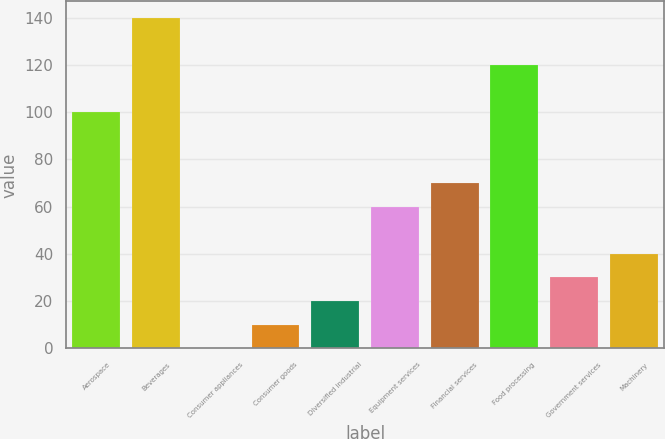<chart> <loc_0><loc_0><loc_500><loc_500><bar_chart><fcel>Aerospace<fcel>Beverages<fcel>Consumer appliances<fcel>Consumer goods<fcel>Diversified industrial<fcel>Equipment services<fcel>Financial services<fcel>Food processing<fcel>Government services<fcel>Machinery<nl><fcel>100<fcel>139.96<fcel>0.1<fcel>10.09<fcel>20.08<fcel>60.04<fcel>70.03<fcel>119.98<fcel>30.07<fcel>40.06<nl></chart> 